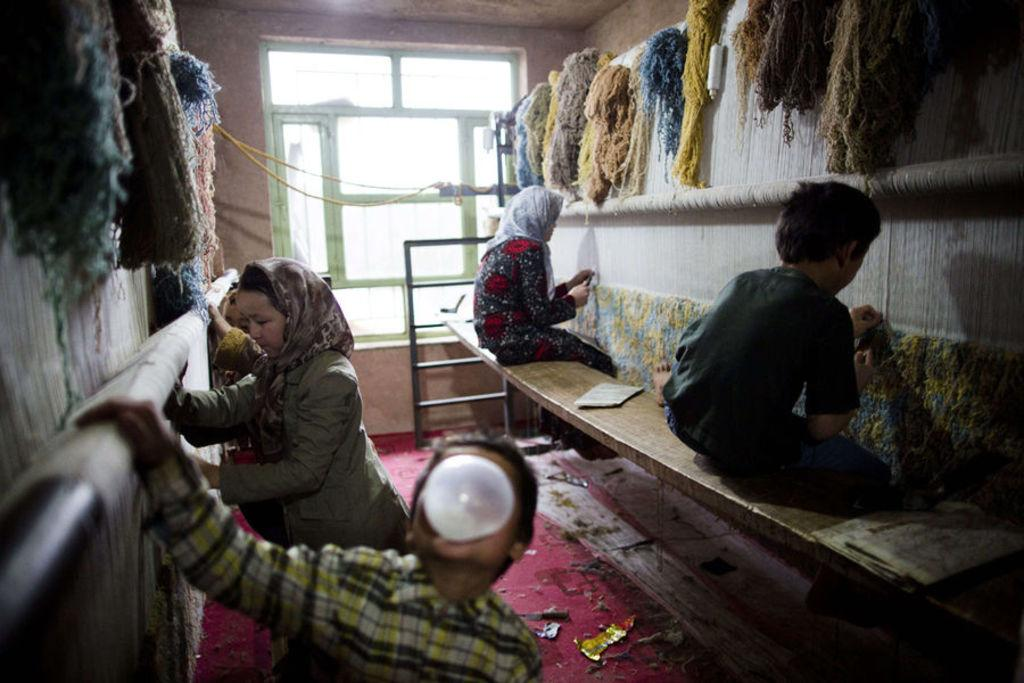How many people are in the image? There is a group of people in the image. What are some of the people in the image doing? Some people are seated on a bench. What objects can be seen in the image besides the people? There are newspapers in the image. What type of material is visible in the image? There are threads visible in the image. What color is the toad sitting on the bench in the image? There is no toad present in the image; it features a group of people and other objects. 